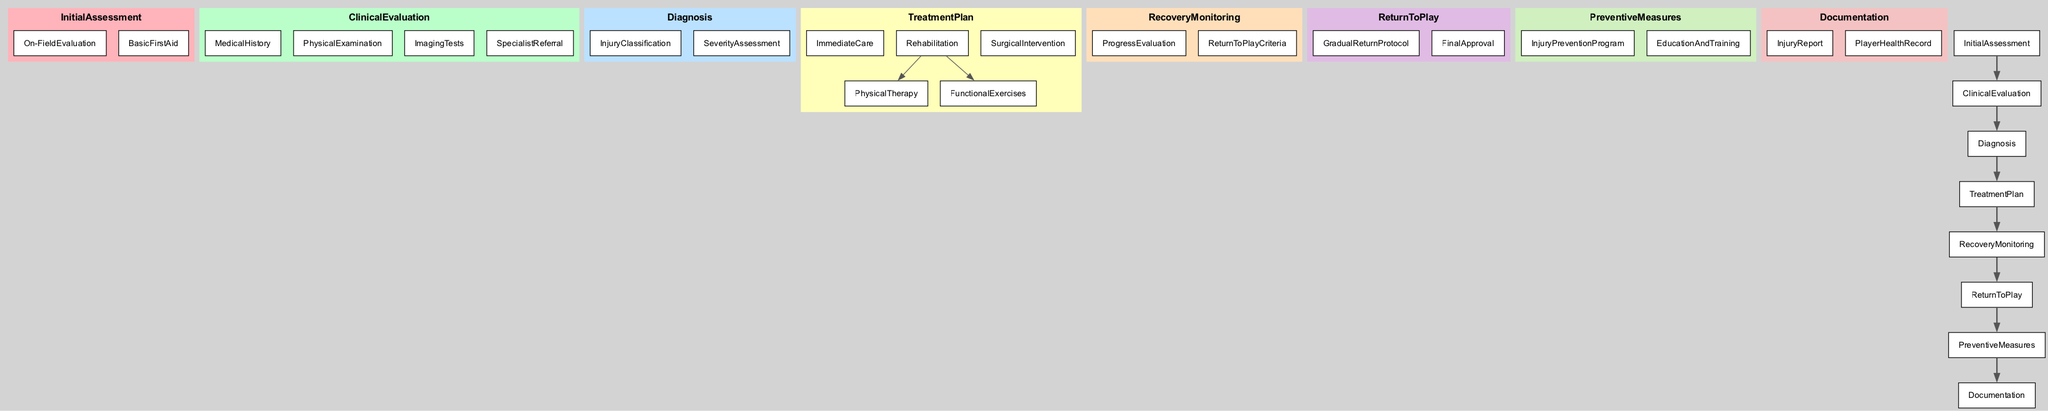What is the first step in the player injury pathway? The diagram indicates that the first step is "Initial Assessment." This is the first main node in the flow of the clinical pathway depicted.
Answer: Initial Assessment How many main steps are there in the clinical pathway? By counting the main sections in the diagram, there are a total of 8 main steps represented.
Answer: 8 What is assessed during the "Diagnosis" phase? The “Diagnosis” phase involves two components: "Injury Classification" and "Severity Assessment." These components help establish a clear understanding of the nature and extent of the injury.
Answer: Injury Classification, Severity Assessment Which phase includes "Physical Therapy" and "Functional Exercises"? These two components are nested under "Rehabilitation," which is a part of the "Treatment Plan." A closer look at the diagram shows that these treatments fall under the same sub-category.
Answer: Rehabilitation What comes after "Recovery Monitoring" in the pathway? Once the "Recovery Monitoring" phase is completed, the next step indicated is "Return to Play." This depicts how the pathway progresses after assessing recovery.
Answer: Return to Play What is the purpose of the "Preventive Measures" step? The "Preventive Measures" step focuses on two key areas: "Injury Prevention Program" and "Education and Training." This step aims to reduce the likelihood of future injuries.
Answer: Injury Prevention Program, Education and Training Which component involves the "Final Approval" for a player to return to play? The "Final Approval" is part of the "Return to Play" section. This indicates that obtaining this approval is crucial before a player is allowed back into activity.
Answer: Return to Play How does "Specialist Referral" fit into the overall pathway? "Specialist Referral" is a part of the "Clinical Evaluation" phase, highlighting the importance of involving specialized medical professionals if required for comprehensive injury assessment.
Answer: Clinical Evaluation What type of documentation is required after an injury? The pathway specifies that an "Injury Report" needs to be completed and filed, along with updating the "Player Health Record" to maintain accurate health documentation.
Answer: Injury Report, Player Health Record 